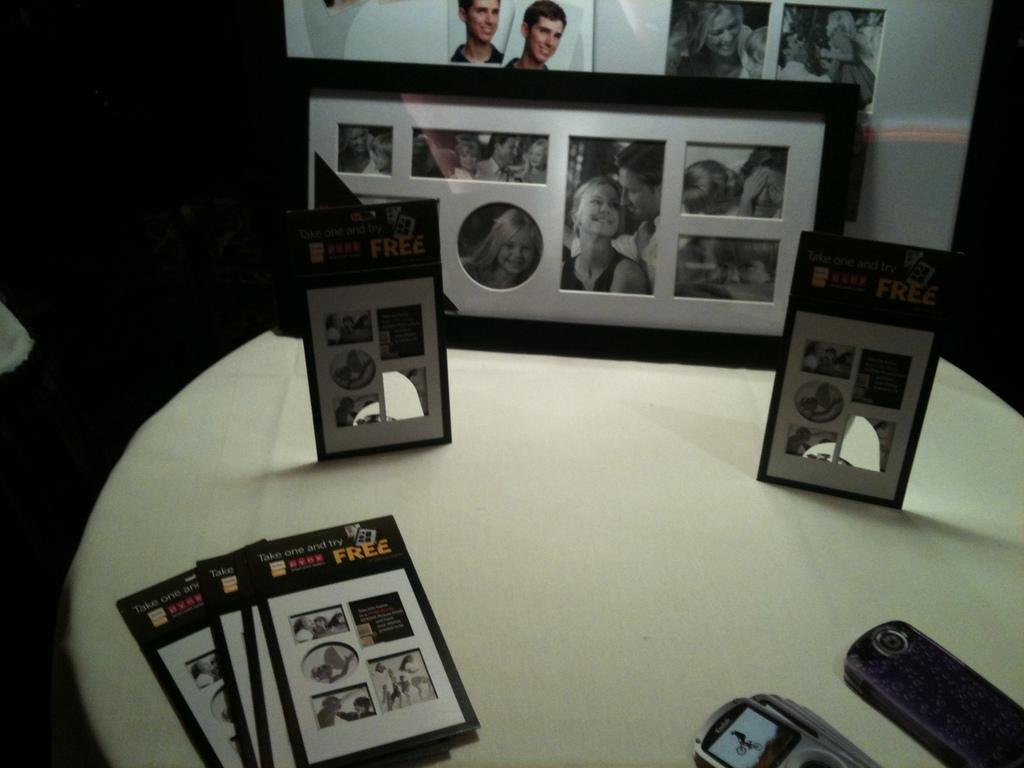<image>
Write a terse but informative summary of the picture. Photographs on a desk show the text "Take one and try FREE." 